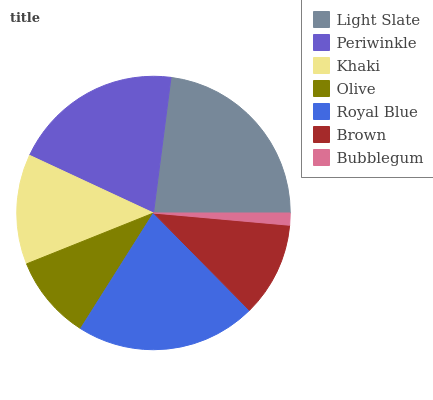Is Bubblegum the minimum?
Answer yes or no. Yes. Is Light Slate the maximum?
Answer yes or no. Yes. Is Periwinkle the minimum?
Answer yes or no. No. Is Periwinkle the maximum?
Answer yes or no. No. Is Light Slate greater than Periwinkle?
Answer yes or no. Yes. Is Periwinkle less than Light Slate?
Answer yes or no. Yes. Is Periwinkle greater than Light Slate?
Answer yes or no. No. Is Light Slate less than Periwinkle?
Answer yes or no. No. Is Khaki the high median?
Answer yes or no. Yes. Is Khaki the low median?
Answer yes or no. Yes. Is Olive the high median?
Answer yes or no. No. Is Royal Blue the low median?
Answer yes or no. No. 